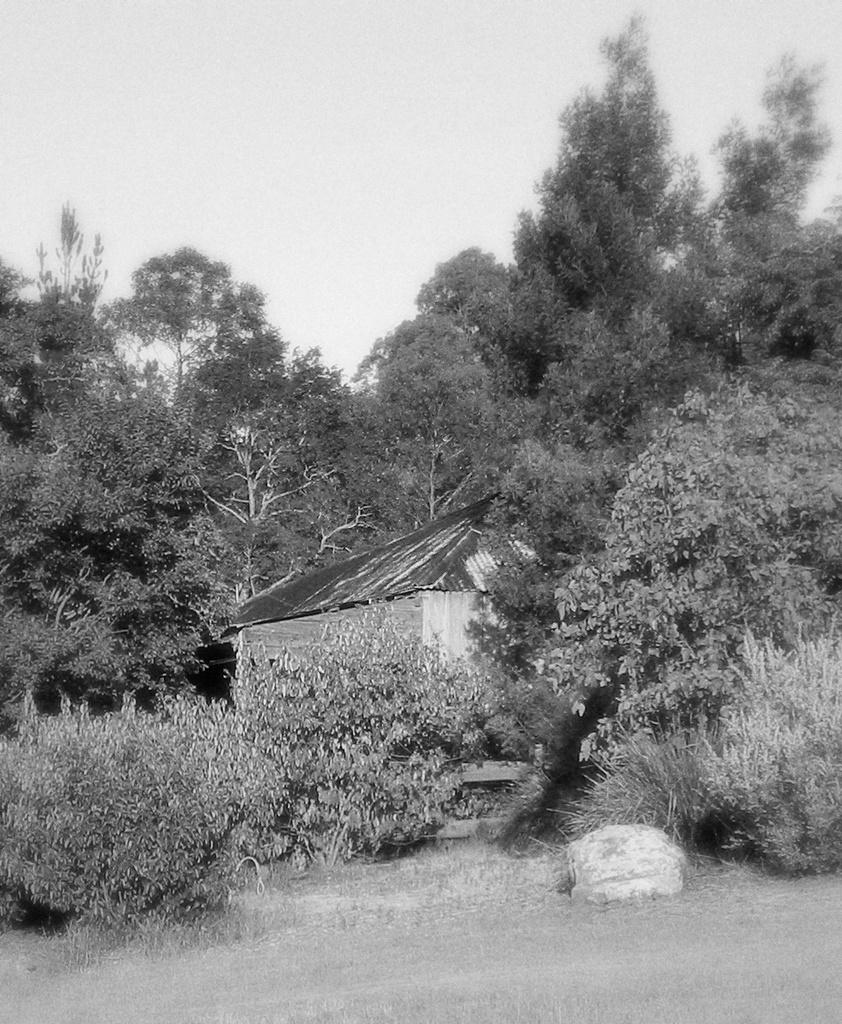What type of vegetation can be seen in the image? The image contains trees and plants. What color is the grass at the bottom of the image? The grass at the bottom of the image is green. What structure is located in the middle of the image? There is a small house in the middle of the image. What type of amusement can be seen in the image? There is no amusement present in the image; it features trees, plants, and a small house. Can you see a screw in the image? There is no screw present in the image. 